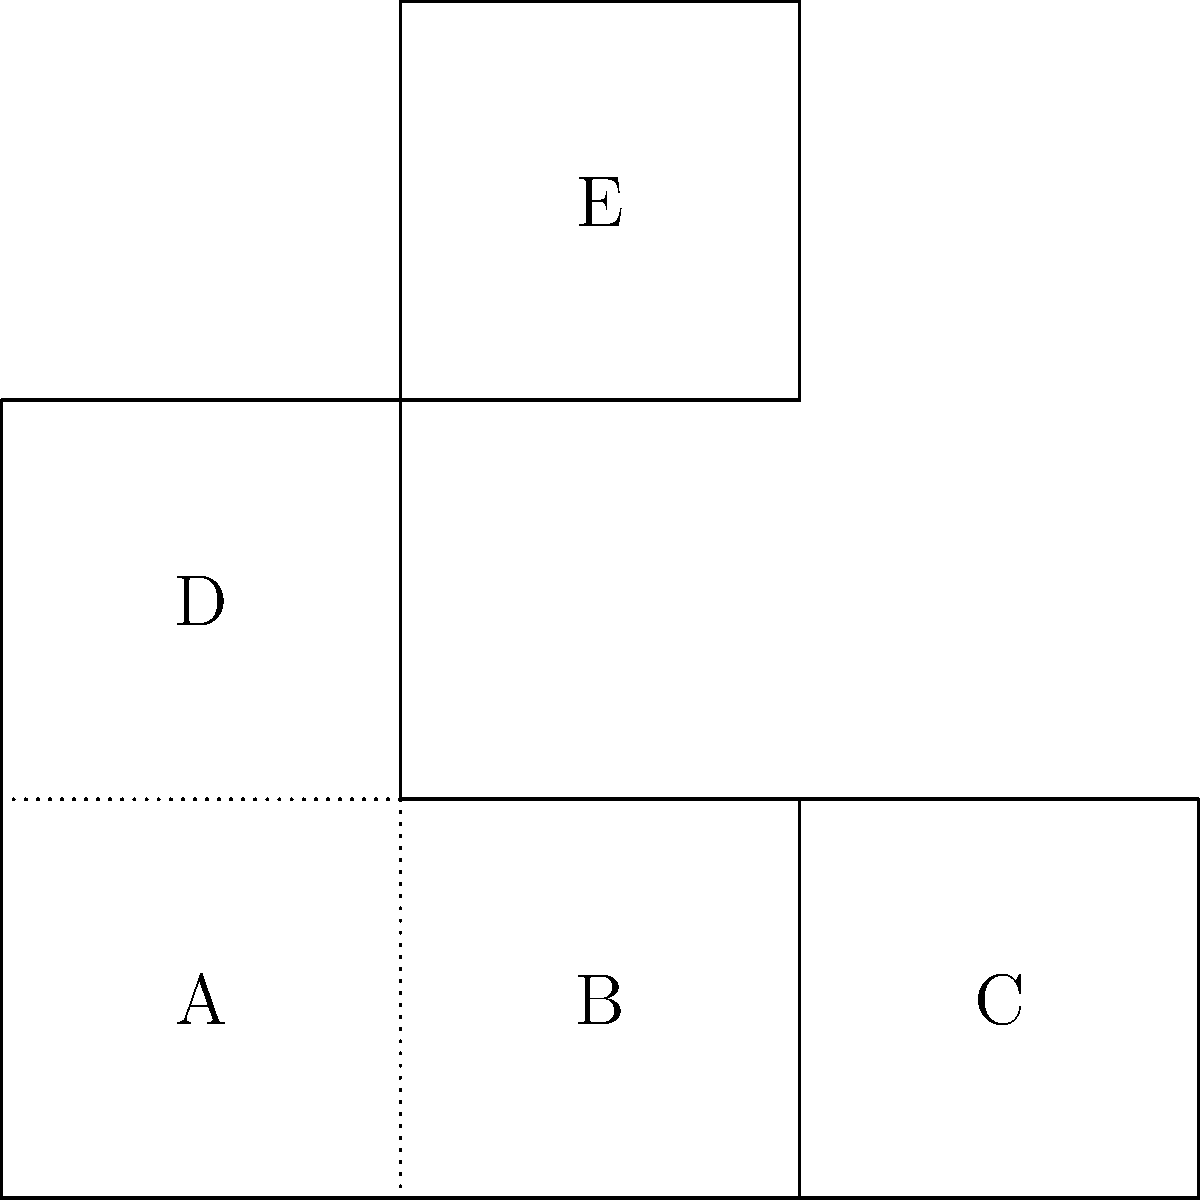The diagram shows an unfolded pattern for a dental prosthetic device. When folded along the dotted lines, which two faces will be opposite each other in the final 3D form? To solve this problem, we need to mentally fold the 2D diagram into its 3D form:

1. First, observe that face B is the central piece, connected to all other faces.
2. Face A folds up 90 degrees along the left edge of B.
3. Face C folds up 90 degrees along the right edge of B.
4. Face D folds up 90 degrees along the top edge of A and B.
5. Face E folds down 90 degrees along the top edge of B.

After folding:
- A and C will be perpendicular to B and parallel to each other.
- D will be perpendicular to A, B, and C.
- E will be perpendicular to B and parallel to D.

The only faces that will be on opposite sides of the 3D form are A and C.
Answer: A and C 